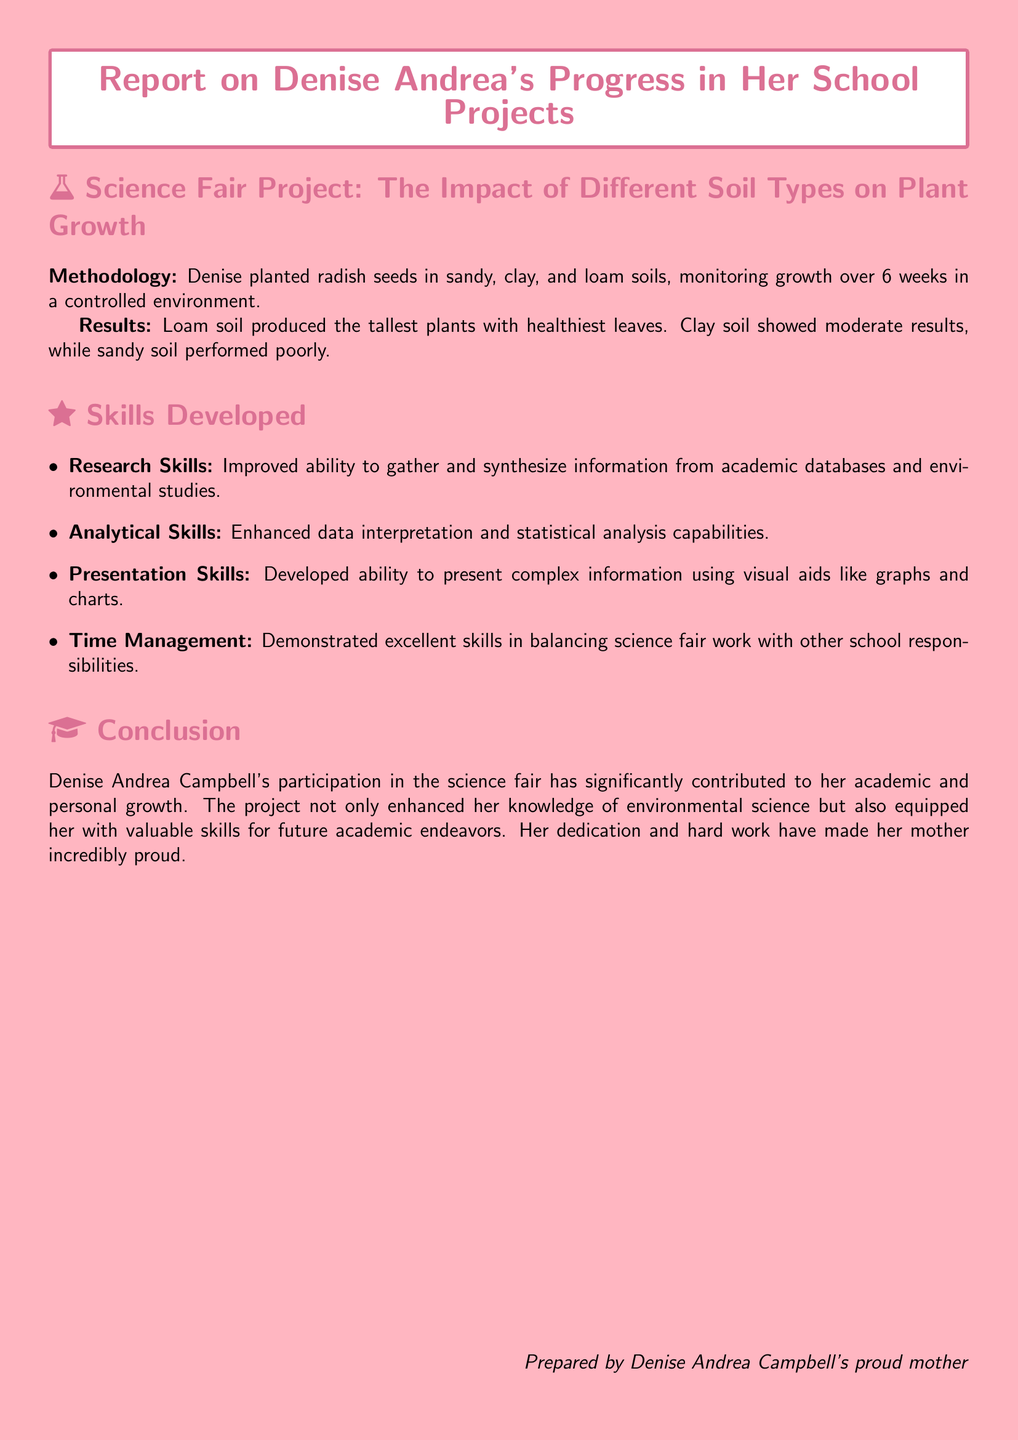What is the focus of the science fair project? The science fair project focuses on the impact of different soil types on plant growth.
Answer: The impact of different soil types on plant growth What are the three soil types used in the project? The project involved sandy, clay, and loam soils.
Answer: Sandy, clay, and loam Which soil produced the tallest plants? The results indicated that loam soil produced the tallest plants.
Answer: Loam soil What key skill related to data interpretation did Denise improve? Denise enhanced her analytical skills, particularly in data interpretation and statistical analysis.
Answer: Analytical Skills How long did Denise monitor the plant growth? The growth of the plants was monitored over 6 weeks.
Answer: 6 weeks What visual aids did Denise use for her presentation? Denise developed the ability to present complex information using visual aids like graphs and charts.
Answer: Graphs and charts What type of project is this document reporting on? The document reports on a school project specifically related to a science fair.
Answer: School project Who prepared the report? The report was prepared by Denise Andrea Campbell's proud mother.
Answer: Denise Andrea Campbell's proud mother 